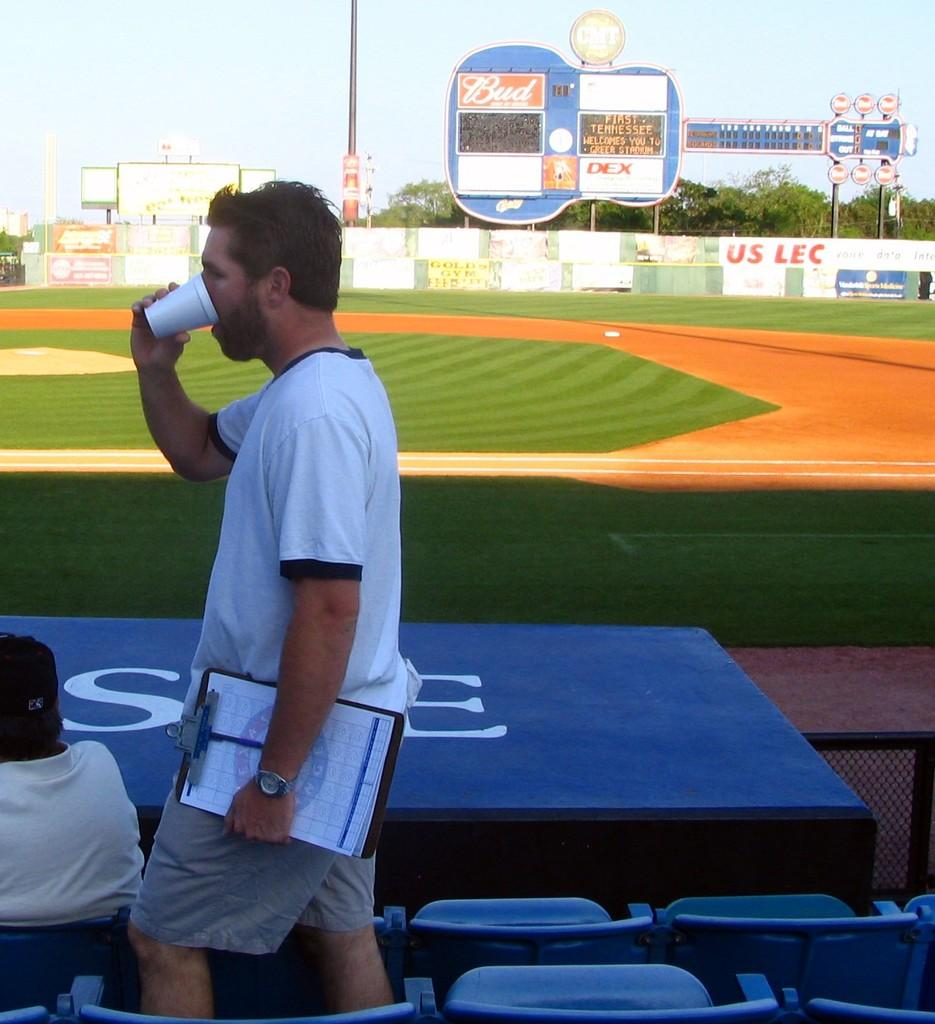Provide a one-sentence caption for the provided image. A couple of fans at a stadium with a guitar shaped scoreboard sponsored by Budweiser. 